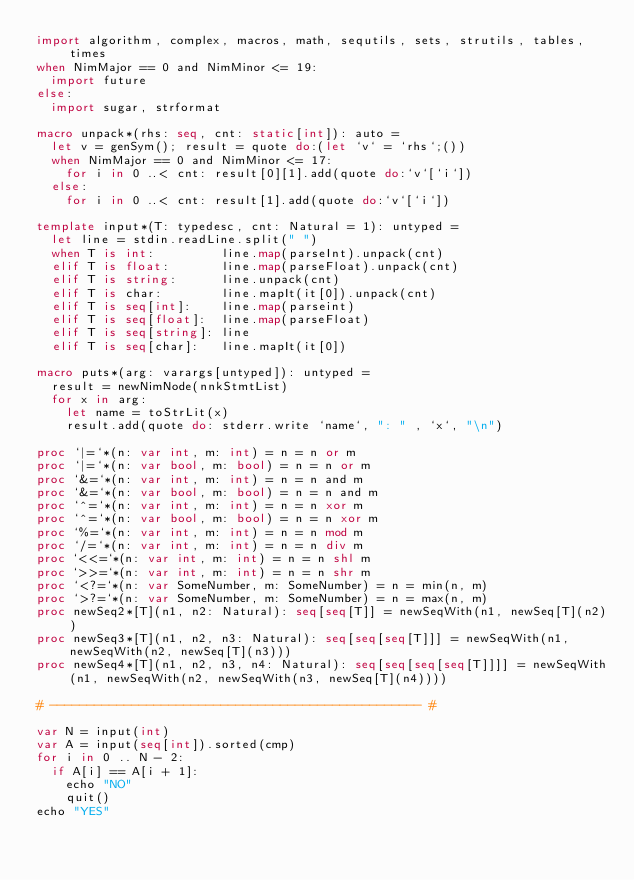Convert code to text. <code><loc_0><loc_0><loc_500><loc_500><_Nim_>import algorithm, complex, macros, math, sequtils, sets, strutils, tables, times
when NimMajor == 0 and NimMinor <= 19:
  import future
else:
  import sugar, strformat

macro unpack*(rhs: seq, cnt: static[int]): auto =
  let v = genSym(); result = quote do:(let `v` = `rhs`;())
  when NimMajor == 0 and NimMinor <= 17:
    for i in 0 ..< cnt: result[0][1].add(quote do:`v`[`i`])
  else:
    for i in 0 ..< cnt: result[1].add(quote do:`v`[`i`])

template input*(T: typedesc, cnt: Natural = 1): untyped =
  let line = stdin.readLine.split(" ")
  when T is int:         line.map(parseInt).unpack(cnt)
  elif T is float:       line.map(parseFloat).unpack(cnt)
  elif T is string:      line.unpack(cnt)
  elif T is char:        line.mapIt(it[0]).unpack(cnt)
  elif T is seq[int]:    line.map(parseint)
  elif T is seq[float]:  line.map(parseFloat)
  elif T is seq[string]: line
  elif T is seq[char]:   line.mapIt(it[0])

macro puts*(arg: varargs[untyped]): untyped =
  result = newNimNode(nnkStmtList)
  for x in arg:
    let name = toStrLit(x)
    result.add(quote do: stderr.write `name`, ": " , `x`, "\n")

proc `|=`*(n: var int, m: int) = n = n or m
proc `|=`*(n: var bool, m: bool) = n = n or m
proc `&=`*(n: var int, m: int) = n = n and m
proc `&=`*(n: var bool, m: bool) = n = n and m
proc `^=`*(n: var int, m: int) = n = n xor m
proc `^=`*(n: var bool, m: bool) = n = n xor m
proc `%=`*(n: var int, m: int) = n = n mod m
proc `/=`*(n: var int, m: int) = n = n div m
proc `<<=`*(n: var int, m: int) = n = n shl m
proc `>>=`*(n: var int, m: int) = n = n shr m
proc `<?=`*(n: var SomeNumber, m: SomeNumber) = n = min(n, m)
proc `>?=`*(n: var SomeNumber, m: SomeNumber) = n = max(n, m)
proc newSeq2*[T](n1, n2: Natural): seq[seq[T]] = newSeqWith(n1, newSeq[T](n2))
proc newSeq3*[T](n1, n2, n3: Natural): seq[seq[seq[T]]] = newSeqWith(n1, newSeqWith(n2, newSeq[T](n3)))
proc newSeq4*[T](n1, n2, n3, n4: Natural): seq[seq[seq[seq[T]]]] = newSeqWith(n1, newSeqWith(n2, newSeqWith(n3, newSeq[T](n4))))

# -------------------------------------------------- #

var N = input(int)
var A = input(seq[int]).sorted(cmp)
for i in 0 .. N - 2:
  if A[i] == A[i + 1]:
    echo "NO"
    quit()
echo "YES"</code> 